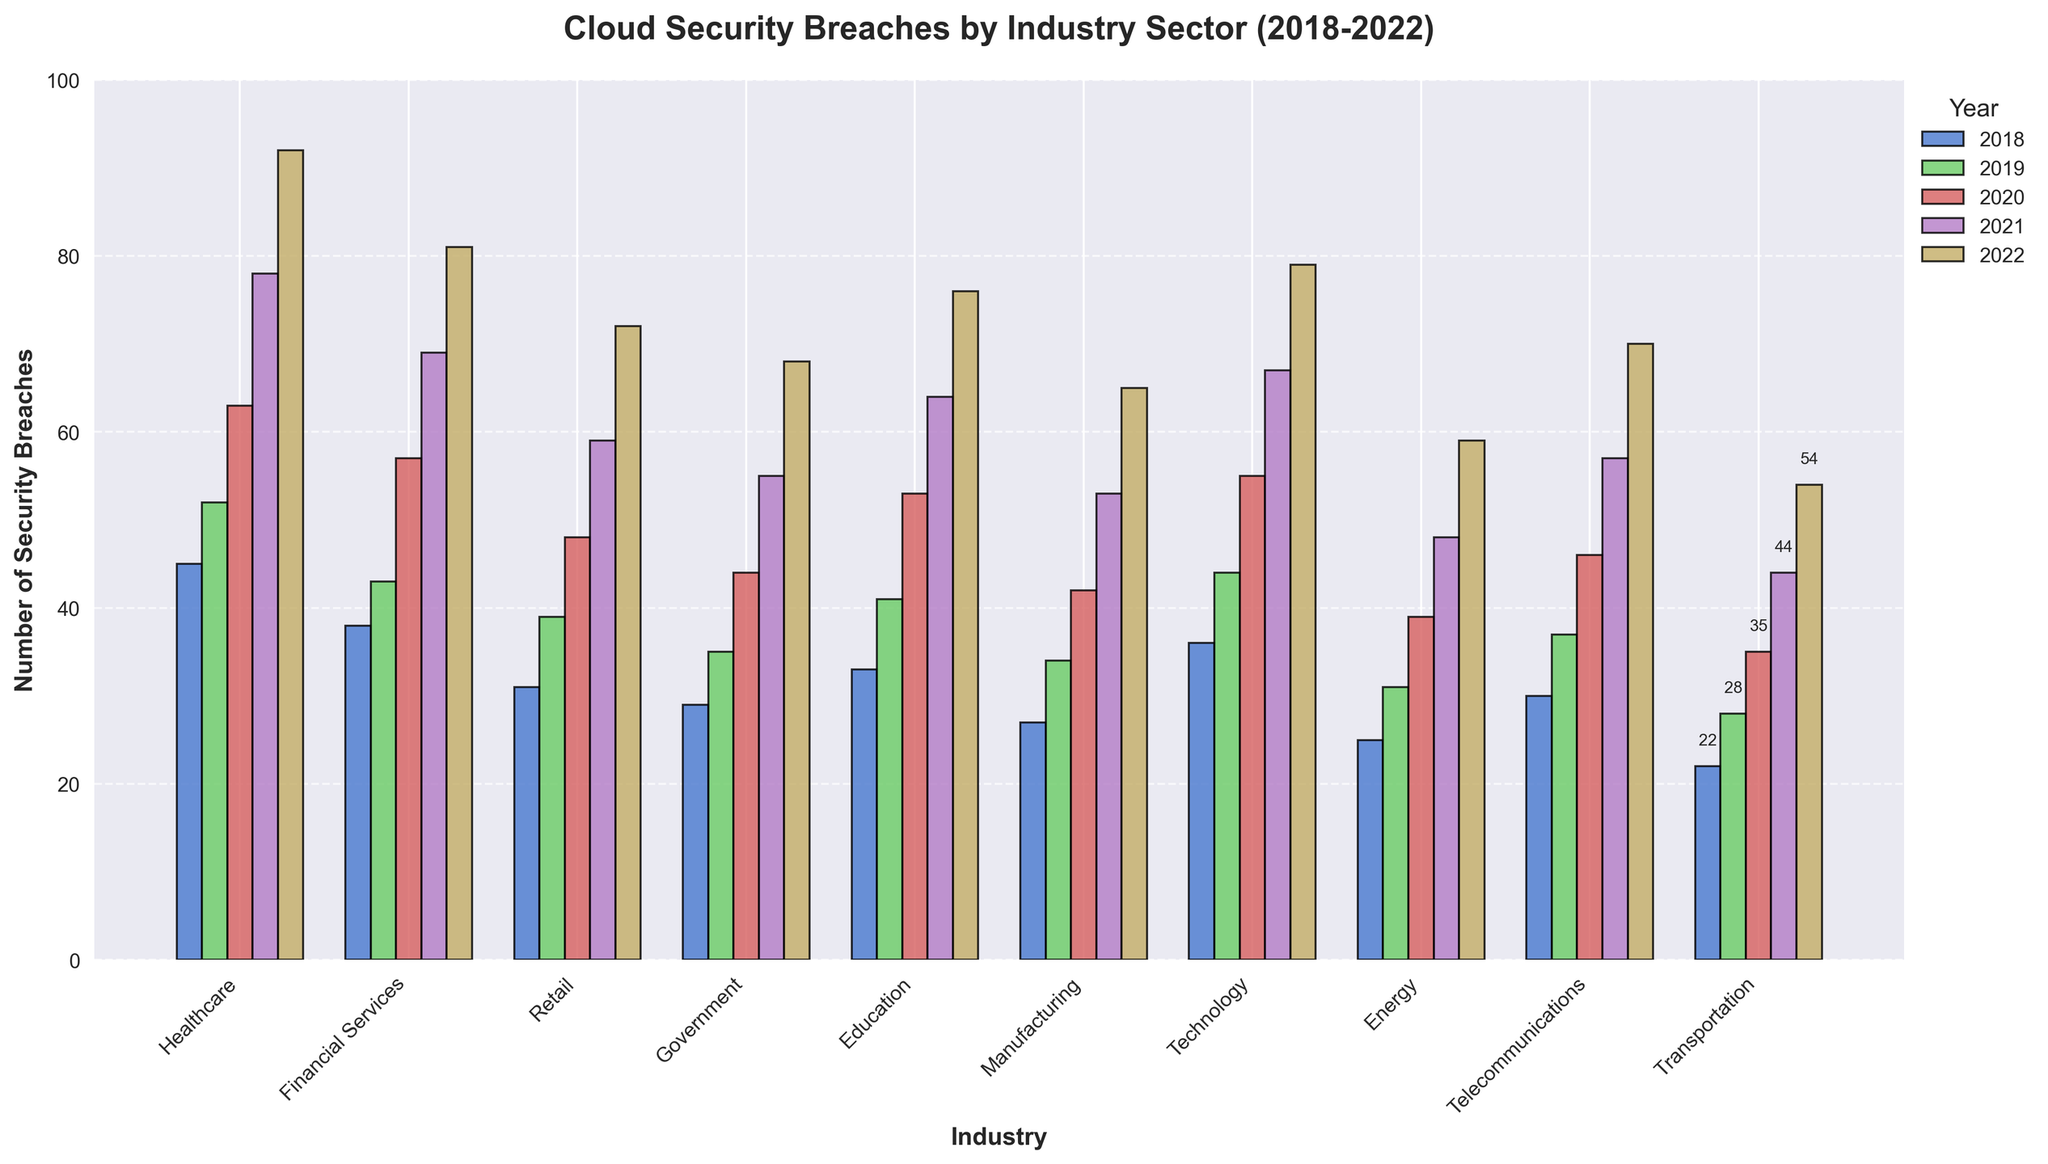What's the overall trend observed in cloud security breaches across all industries from 2018 to 2022? By examining each industry sector’s bars, it's evident that the bars' heights increase consistently from 2018 to 2022, indicating a rising trend in the number of cloud security breaches over these years.
Answer: An increasing trend Which industry experienced the highest number of cloud security breaches in 2022? In 2022, the tallest bar corresponds to the Healthcare industry, indicating that it experienced the highest number of security breaches.
Answer: Healthcare How does the number of breaches in the Financial Services sector in 2020 compare to the number in the Retail sector in 2020? In 2020, the bars for the Financial Services and Retail sectors show 57 and 48 breaches, respectively. The Financial Services sector has more breaches than the Retail sector in that year.
Answer: Financial Services has more breaches What is the total number of breaches across all industries in 2019? Sum the number of breaches for each industry in 2019: 52 (Healthcare) + 43 (Financial Services) + 39 (Retail) + 35 (Government) + 41 (Education) + 34 (Manufacturing) + 44 (Technology) + 31 (Energy) + 37 (Telecommunications) + 28 (Transportation). The total is 384 breaches.
Answer: 384 By how much did the Telecom sector's breaches increase from 2018 to 2022? Subtract the number of breaches in 2018 from the number in 2022 for the Telecom sector: 70 (2022) - 30 (2018). The increase is 40 breaches.
Answer: 40 Which sector showed the least number of breaches in 2021? The shortest bar in the 2021 grouping corresponds to the Energy sector, indicating it has the least number of breaches in that year.
Answer: Energy On average, how many breaches did the Manufacturing sector experience per year between 2018 and 2022? The total number of breaches in the Manufacturing sector over 5 years is 27 + 34 + 42 + 53 + 65 = 221 breaches. The average per year is 221 / 5 = 44.2 breaches.
Answer: 44.2 Which two sectors showed the closest number of breaches in 2019, and what were those numbers? The bars for Financial Services and Education in 2019 are closest in height, both having 43 breaches.
Answer: Financial Services and Education, both 43 Compare the total breaches in the Healthcare sector to the total breaches in the Retail sector from 2018 to 2022. Which sector had more? Sum the breaches for 2018-2022 for Healthcare: 45 + 52 + 63 + 78 + 92 = 330. For Retail: 31 + 39 + 48 + 59 + 72 = 249. The Healthcare sector had more breaches overall.
Answer: Healthcare had more Between 2019 and 2021, which industry showed the largest increase in the number of breaches? Calculate the difference for each industry between 2019 and 2021. For example, for Healthcare: 78 - 52 = 26. After calculating for all, Healthcare shows the largest increase of 26 breaches.
Answer: Healthcare 